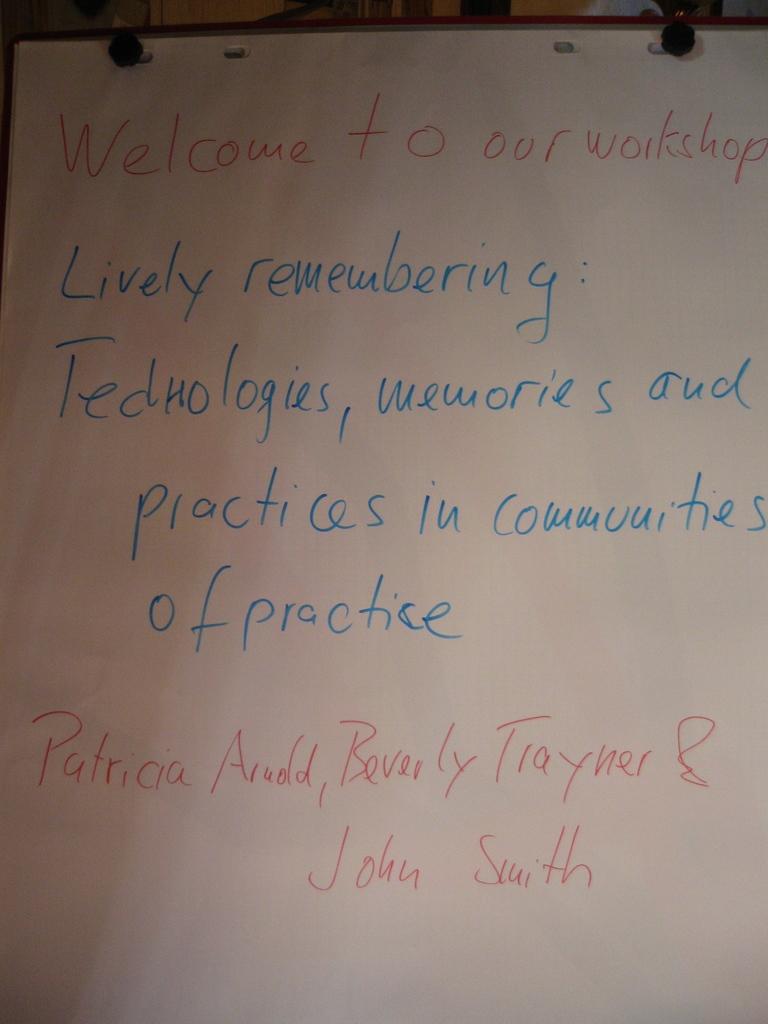What is the man hosting?
Offer a very short reply. Workshop. 